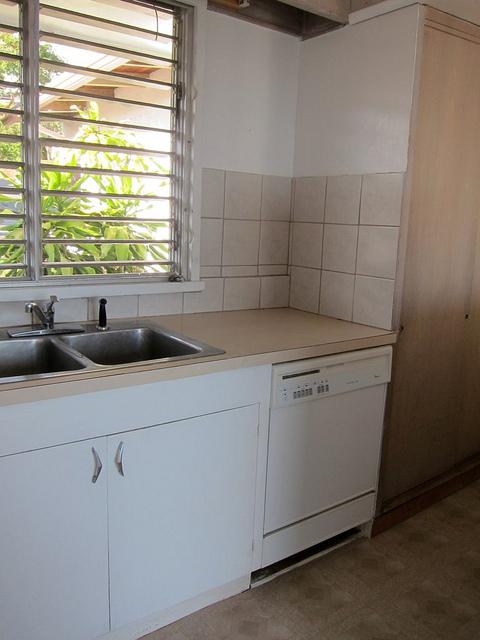Is this a large kitchen?
Give a very brief answer. No. Are the two sides of the sink divided equally?
Be succinct. Yes. Are there pictures on the wall?
Concise answer only. No. What color is the kitchen cabinet?
Keep it brief. White. 